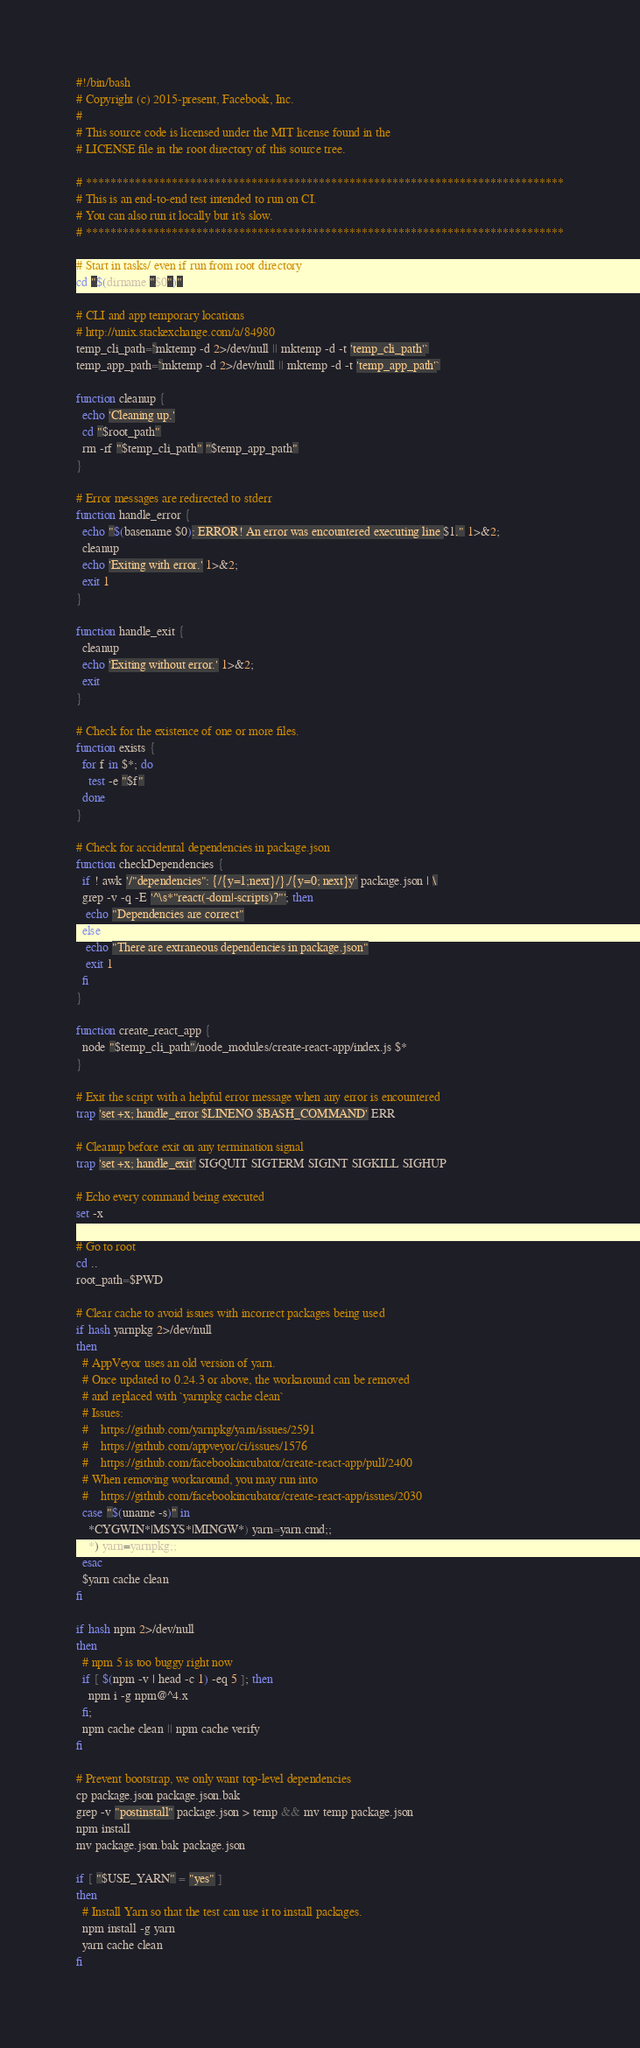Convert code to text. <code><loc_0><loc_0><loc_500><loc_500><_Bash_>#!/bin/bash
# Copyright (c) 2015-present, Facebook, Inc.
#
# This source code is licensed under the MIT license found in the
# LICENSE file in the root directory of this source tree.

# ******************************************************************************
# This is an end-to-end test intended to run on CI.
# You can also run it locally but it's slow.
# ******************************************************************************

# Start in tasks/ even if run from root directory
cd "$(dirname "$0")"

# CLI and app temporary locations
# http://unix.stackexchange.com/a/84980
temp_cli_path=`mktemp -d 2>/dev/null || mktemp -d -t 'temp_cli_path'`
temp_app_path=`mktemp -d 2>/dev/null || mktemp -d -t 'temp_app_path'`

function cleanup {
  echo 'Cleaning up.'
  cd "$root_path"
  rm -rf "$temp_cli_path" "$temp_app_path"
}

# Error messages are redirected to stderr
function handle_error {
  echo "$(basename $0): ERROR! An error was encountered executing line $1." 1>&2;
  cleanup
  echo 'Exiting with error.' 1>&2;
  exit 1
}

function handle_exit {
  cleanup
  echo 'Exiting without error.' 1>&2;
  exit
}

# Check for the existence of one or more files.
function exists {
  for f in $*; do
    test -e "$f"
  done
}

# Check for accidental dependencies in package.json
function checkDependencies {
  if ! awk '/"dependencies": {/{y=1;next}/},/{y=0; next}y' package.json | \
  grep -v -q -E '^\s*"react(-dom|-scripts)?"'; then
   echo "Dependencies are correct"
  else
   echo "There are extraneous dependencies in package.json"
   exit 1
  fi
}

function create_react_app {
  node "$temp_cli_path"/node_modules/create-react-app/index.js $*
}

# Exit the script with a helpful error message when any error is encountered
trap 'set +x; handle_error $LINENO $BASH_COMMAND' ERR

# Cleanup before exit on any termination signal
trap 'set +x; handle_exit' SIGQUIT SIGTERM SIGINT SIGKILL SIGHUP

# Echo every command being executed
set -x

# Go to root
cd ..
root_path=$PWD

# Clear cache to avoid issues with incorrect packages being used
if hash yarnpkg 2>/dev/null
then
  # AppVeyor uses an old version of yarn.
  # Once updated to 0.24.3 or above, the workaround can be removed
  # and replaced with `yarnpkg cache clean`
  # Issues:
  #    https://github.com/yarnpkg/yarn/issues/2591
  #    https://github.com/appveyor/ci/issues/1576
  #    https://github.com/facebookincubator/create-react-app/pull/2400
  # When removing workaround, you may run into
  #    https://github.com/facebookincubator/create-react-app/issues/2030
  case "$(uname -s)" in
    *CYGWIN*|MSYS*|MINGW*) yarn=yarn.cmd;;
    *) yarn=yarnpkg;;
  esac
  $yarn cache clean
fi

if hash npm 2>/dev/null
then
  # npm 5 is too buggy right now
  if [ $(npm -v | head -c 1) -eq 5 ]; then
    npm i -g npm@^4.x
  fi;
  npm cache clean || npm cache verify
fi

# Prevent bootstrap, we only want top-level dependencies
cp package.json package.json.bak
grep -v "postinstall" package.json > temp && mv temp package.json
npm install
mv package.json.bak package.json

if [ "$USE_YARN" = "yes" ]
then
  # Install Yarn so that the test can use it to install packages.
  npm install -g yarn
  yarn cache clean
fi
</code> 